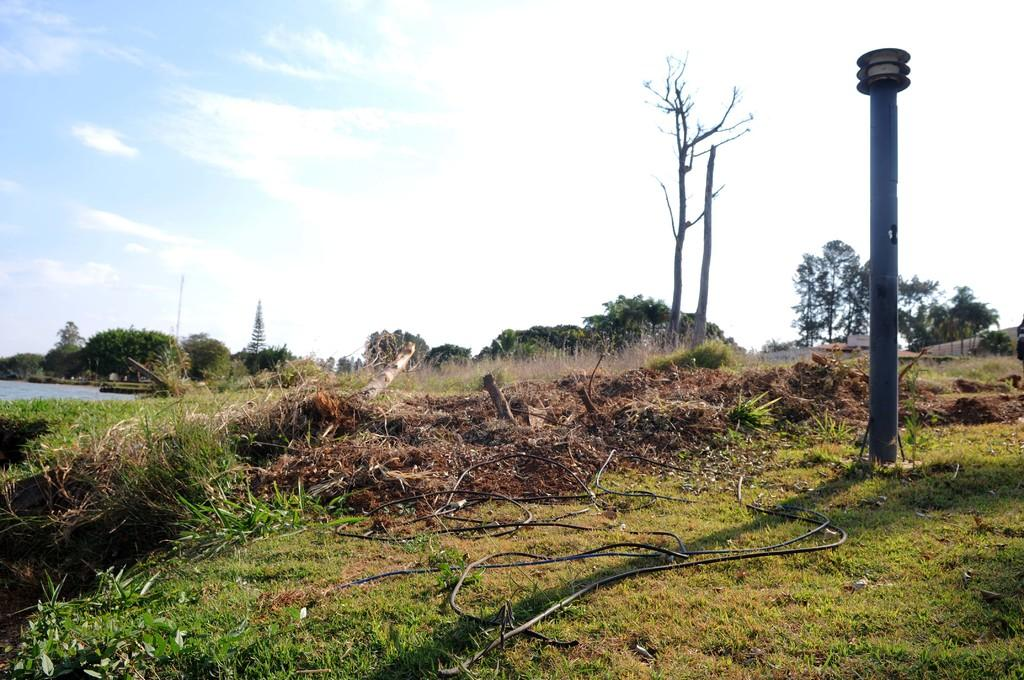What is the main object in the image? There is a pole in the image. How is the pole connected to the ground? The pole is attached to the ground. What type of vegetation is present on the ground? Grass is present on the ground. What is attached to the pole? There are cables on the pole. What can be seen in the background of the image? Water, trees, and clouds are visible in the background. What is the color of the sky in the image? The sky is blue in the image. How much sugar is dissolved in the water visible in the background? There is no information about sugar or its dissolution in the water visible in the background. 